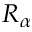Convert formula to latex. <formula><loc_0><loc_0><loc_500><loc_500>R _ { \alpha }</formula> 